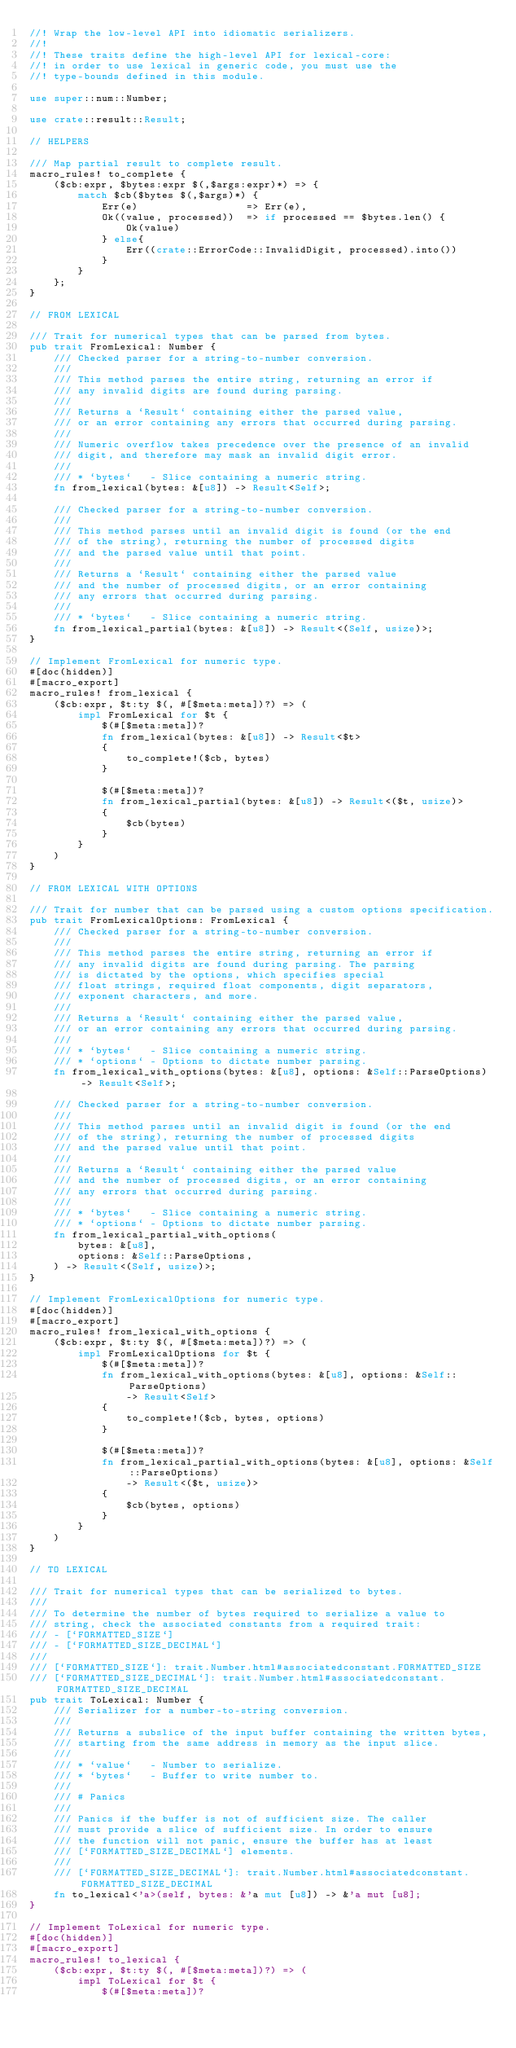<code> <loc_0><loc_0><loc_500><loc_500><_Rust_>//! Wrap the low-level API into idiomatic serializers.
//!
//! These traits define the high-level API for lexical-core:
//! in order to use lexical in generic code, you must use the
//! type-bounds defined in this module.

use super::num::Number;

use crate::result::Result;

// HELPERS

/// Map partial result to complete result.
macro_rules! to_complete {
    ($cb:expr, $bytes:expr $(,$args:expr)*) => {
        match $cb($bytes $(,$args)*) {
            Err(e)                  => Err(e),
            Ok((value, processed))  => if processed == $bytes.len() {
                Ok(value)
            } else{
                Err((crate::ErrorCode::InvalidDigit, processed).into())
            }
        }
    };
}

// FROM LEXICAL

/// Trait for numerical types that can be parsed from bytes.
pub trait FromLexical: Number {
    /// Checked parser for a string-to-number conversion.
    ///
    /// This method parses the entire string, returning an error if
    /// any invalid digits are found during parsing.
    ///
    /// Returns a `Result` containing either the parsed value,
    /// or an error containing any errors that occurred during parsing.
    ///
    /// Numeric overflow takes precedence over the presence of an invalid
    /// digit, and therefore may mask an invalid digit error.
    ///
    /// * `bytes`   - Slice containing a numeric string.
    fn from_lexical(bytes: &[u8]) -> Result<Self>;

    /// Checked parser for a string-to-number conversion.
    ///
    /// This method parses until an invalid digit is found (or the end
    /// of the string), returning the number of processed digits
    /// and the parsed value until that point.
    ///
    /// Returns a `Result` containing either the parsed value
    /// and the number of processed digits, or an error containing
    /// any errors that occurred during parsing.
    ///
    /// * `bytes`   - Slice containing a numeric string.
    fn from_lexical_partial(bytes: &[u8]) -> Result<(Self, usize)>;
}

// Implement FromLexical for numeric type.
#[doc(hidden)]
#[macro_export]
macro_rules! from_lexical {
    ($cb:expr, $t:ty $(, #[$meta:meta])?) => (
        impl FromLexical for $t {
            $(#[$meta:meta])?
            fn from_lexical(bytes: &[u8]) -> Result<$t>
            {
                to_complete!($cb, bytes)
            }

            $(#[$meta:meta])?
            fn from_lexical_partial(bytes: &[u8]) -> Result<($t, usize)>
            {
                $cb(bytes)
            }
        }
    )
}

// FROM LEXICAL WITH OPTIONS

/// Trait for number that can be parsed using a custom options specification.
pub trait FromLexicalOptions: FromLexical {
    /// Checked parser for a string-to-number conversion.
    ///
    /// This method parses the entire string, returning an error if
    /// any invalid digits are found during parsing. The parsing
    /// is dictated by the options, which specifies special
    /// float strings, required float components, digit separators,
    /// exponent characters, and more.
    ///
    /// Returns a `Result` containing either the parsed value,
    /// or an error containing any errors that occurred during parsing.
    ///
    /// * `bytes`   - Slice containing a numeric string.
    /// * `options` - Options to dictate number parsing.
    fn from_lexical_with_options(bytes: &[u8], options: &Self::ParseOptions) -> Result<Self>;

    /// Checked parser for a string-to-number conversion.
    ///
    /// This method parses until an invalid digit is found (or the end
    /// of the string), returning the number of processed digits
    /// and the parsed value until that point.
    ///
    /// Returns a `Result` containing either the parsed value
    /// and the number of processed digits, or an error containing
    /// any errors that occurred during parsing.
    ///
    /// * `bytes`   - Slice containing a numeric string.
    /// * `options` - Options to dictate number parsing.
    fn from_lexical_partial_with_options(
        bytes: &[u8],
        options: &Self::ParseOptions,
    ) -> Result<(Self, usize)>;
}

// Implement FromLexicalOptions for numeric type.
#[doc(hidden)]
#[macro_export]
macro_rules! from_lexical_with_options {
    ($cb:expr, $t:ty $(, #[$meta:meta])?) => (
        impl FromLexicalOptions for $t {
            $(#[$meta:meta])?
            fn from_lexical_with_options(bytes: &[u8], options: &Self::ParseOptions)
                -> Result<Self>
            {
                to_complete!($cb, bytes, options)
            }

            $(#[$meta:meta])?
            fn from_lexical_partial_with_options(bytes: &[u8], options: &Self::ParseOptions)
                -> Result<($t, usize)>
            {
                $cb(bytes, options)
            }
        }
    )
}

// TO LEXICAL

/// Trait for numerical types that can be serialized to bytes.
///
/// To determine the number of bytes required to serialize a value to
/// string, check the associated constants from a required trait:
/// - [`FORMATTED_SIZE`]
/// - [`FORMATTED_SIZE_DECIMAL`]
///
/// [`FORMATTED_SIZE`]: trait.Number.html#associatedconstant.FORMATTED_SIZE
/// [`FORMATTED_SIZE_DECIMAL`]: trait.Number.html#associatedconstant.FORMATTED_SIZE_DECIMAL
pub trait ToLexical: Number {
    /// Serializer for a number-to-string conversion.
    ///
    /// Returns a subslice of the input buffer containing the written bytes,
    /// starting from the same address in memory as the input slice.
    ///
    /// * `value`   - Number to serialize.
    /// * `bytes`   - Buffer to write number to.
    ///
    /// # Panics
    ///
    /// Panics if the buffer is not of sufficient size. The caller
    /// must provide a slice of sufficient size. In order to ensure
    /// the function will not panic, ensure the buffer has at least
    /// [`FORMATTED_SIZE_DECIMAL`] elements.
    ///
    /// [`FORMATTED_SIZE_DECIMAL`]: trait.Number.html#associatedconstant.FORMATTED_SIZE_DECIMAL
    fn to_lexical<'a>(self, bytes: &'a mut [u8]) -> &'a mut [u8];
}

// Implement ToLexical for numeric type.
#[doc(hidden)]
#[macro_export]
macro_rules! to_lexical {
    ($cb:expr, $t:ty $(, #[$meta:meta])?) => (
        impl ToLexical for $t {
            $(#[$meta:meta])?</code> 